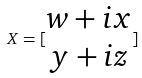Convert formula to latex. <formula><loc_0><loc_0><loc_500><loc_500>X = [ \begin{matrix} w + i x \\ y + i z \end{matrix} ]</formula> 